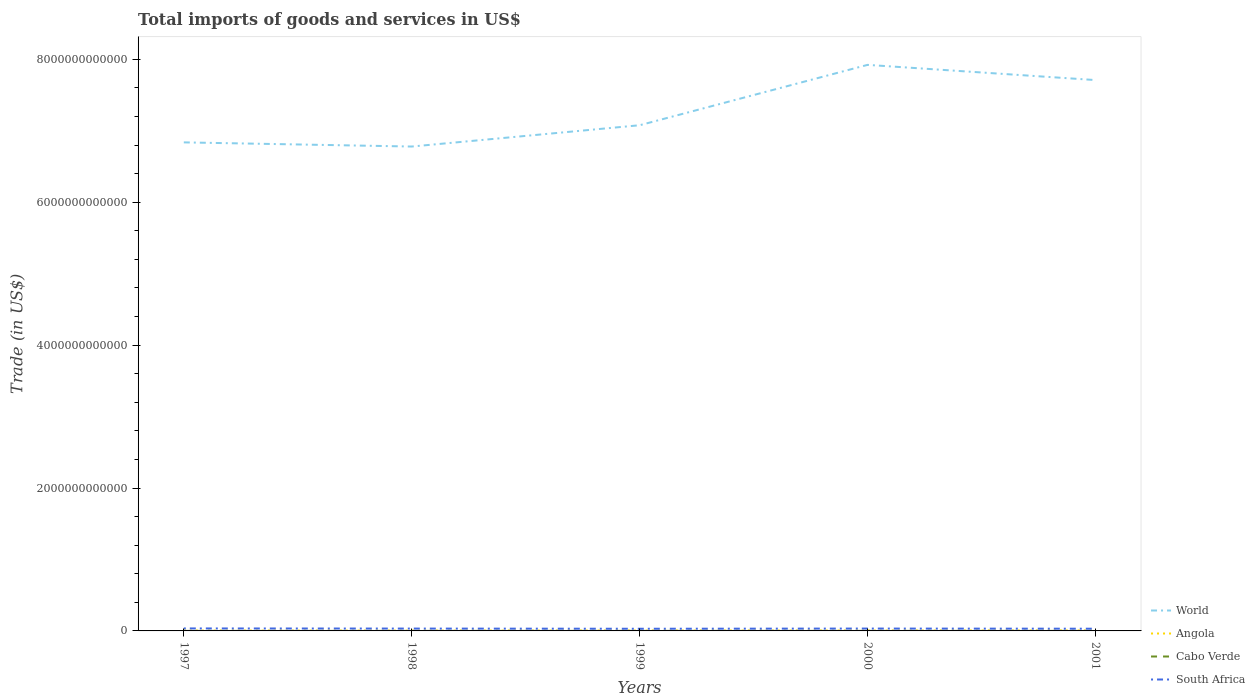How many different coloured lines are there?
Make the answer very short. 4. Across all years, what is the maximum total imports of goods and services in Cabo Verde?
Your response must be concise. 2.87e+08. What is the total total imports of goods and services in Cabo Verde in the graph?
Keep it short and to the point. 4.34e+06. What is the difference between the highest and the second highest total imports of goods and services in Angola?
Keep it short and to the point. 1.98e+09. What is the difference between the highest and the lowest total imports of goods and services in South Africa?
Provide a short and direct response. 3. How many lines are there?
Offer a terse response. 4. What is the difference between two consecutive major ticks on the Y-axis?
Make the answer very short. 2.00e+12. Does the graph contain grids?
Give a very brief answer. No. How are the legend labels stacked?
Keep it short and to the point. Vertical. What is the title of the graph?
Offer a terse response. Total imports of goods and services in US$. Does "Lao PDR" appear as one of the legend labels in the graph?
Your answer should be compact. No. What is the label or title of the X-axis?
Give a very brief answer. Years. What is the label or title of the Y-axis?
Offer a terse response. Trade (in US$). What is the Trade (in US$) in World in 1997?
Ensure brevity in your answer.  6.84e+12. What is the Trade (in US$) of Angola in 1997?
Provide a short and direct response. 5.29e+09. What is the Trade (in US$) in Cabo Verde in 1997?
Offer a very short reply. 2.87e+08. What is the Trade (in US$) of South Africa in 1997?
Provide a succinct answer. 3.49e+1. What is the Trade (in US$) of World in 1998?
Provide a short and direct response. 6.78e+12. What is the Trade (in US$) in Angola in 1998?
Give a very brief answer. 4.71e+09. What is the Trade (in US$) of Cabo Verde in 1998?
Your response must be concise. 3.08e+08. What is the Trade (in US$) in South Africa in 1998?
Give a very brief answer. 3.29e+1. What is the Trade (in US$) of World in 1999?
Make the answer very short. 7.08e+12. What is the Trade (in US$) in Angola in 1999?
Your answer should be very brief. 5.70e+09. What is the Trade (in US$) in Cabo Verde in 1999?
Provide a short and direct response. 3.55e+08. What is the Trade (in US$) of South Africa in 1999?
Your response must be concise. 3.03e+1. What is the Trade (in US$) of World in 2000?
Your response must be concise. 7.92e+12. What is the Trade (in US$) of Angola in 2000?
Your answer should be compact. 5.74e+09. What is the Trade (in US$) of Cabo Verde in 2000?
Ensure brevity in your answer.  3.26e+08. What is the Trade (in US$) of South Africa in 2000?
Provide a short and direct response. 3.31e+1. What is the Trade (in US$) of World in 2001?
Make the answer very short. 7.71e+12. What is the Trade (in US$) in Angola in 2001?
Provide a short and direct response. 6.70e+09. What is the Trade (in US$) of Cabo Verde in 2001?
Your answer should be compact. 3.51e+08. What is the Trade (in US$) in South Africa in 2001?
Your answer should be compact. 3.09e+1. Across all years, what is the maximum Trade (in US$) in World?
Make the answer very short. 7.92e+12. Across all years, what is the maximum Trade (in US$) in Angola?
Provide a short and direct response. 6.70e+09. Across all years, what is the maximum Trade (in US$) of Cabo Verde?
Provide a short and direct response. 3.55e+08. Across all years, what is the maximum Trade (in US$) in South Africa?
Your response must be concise. 3.49e+1. Across all years, what is the minimum Trade (in US$) in World?
Make the answer very short. 6.78e+12. Across all years, what is the minimum Trade (in US$) of Angola?
Provide a short and direct response. 4.71e+09. Across all years, what is the minimum Trade (in US$) of Cabo Verde?
Your response must be concise. 2.87e+08. Across all years, what is the minimum Trade (in US$) of South Africa?
Provide a short and direct response. 3.03e+1. What is the total Trade (in US$) in World in the graph?
Give a very brief answer. 3.63e+13. What is the total Trade (in US$) in Angola in the graph?
Give a very brief answer. 2.81e+1. What is the total Trade (in US$) of Cabo Verde in the graph?
Make the answer very short. 1.63e+09. What is the total Trade (in US$) in South Africa in the graph?
Your response must be concise. 1.62e+11. What is the difference between the Trade (in US$) in World in 1997 and that in 1998?
Your answer should be compact. 5.82e+1. What is the difference between the Trade (in US$) in Angola in 1997 and that in 1998?
Keep it short and to the point. 5.78e+08. What is the difference between the Trade (in US$) in Cabo Verde in 1997 and that in 1998?
Keep it short and to the point. -2.12e+07. What is the difference between the Trade (in US$) in South Africa in 1997 and that in 1998?
Ensure brevity in your answer.  1.96e+09. What is the difference between the Trade (in US$) in World in 1997 and that in 1999?
Your answer should be very brief. -2.40e+11. What is the difference between the Trade (in US$) of Angola in 1997 and that in 1999?
Provide a succinct answer. -4.11e+08. What is the difference between the Trade (in US$) in Cabo Verde in 1997 and that in 1999?
Your answer should be compact. -6.82e+07. What is the difference between the Trade (in US$) of South Africa in 1997 and that in 1999?
Offer a very short reply. 4.59e+09. What is the difference between the Trade (in US$) of World in 1997 and that in 2000?
Your response must be concise. -1.08e+12. What is the difference between the Trade (in US$) in Angola in 1997 and that in 2000?
Your response must be concise. -4.44e+08. What is the difference between the Trade (in US$) in Cabo Verde in 1997 and that in 2000?
Your response must be concise. -3.91e+07. What is the difference between the Trade (in US$) of South Africa in 1997 and that in 2000?
Your answer should be very brief. 1.77e+09. What is the difference between the Trade (in US$) in World in 1997 and that in 2001?
Provide a succinct answer. -8.72e+11. What is the difference between the Trade (in US$) in Angola in 1997 and that in 2001?
Your answer should be compact. -1.41e+09. What is the difference between the Trade (in US$) in Cabo Verde in 1997 and that in 2001?
Give a very brief answer. -6.39e+07. What is the difference between the Trade (in US$) of South Africa in 1997 and that in 2001?
Provide a short and direct response. 3.98e+09. What is the difference between the Trade (in US$) of World in 1998 and that in 1999?
Keep it short and to the point. -2.98e+11. What is the difference between the Trade (in US$) in Angola in 1998 and that in 1999?
Provide a succinct answer. -9.89e+08. What is the difference between the Trade (in US$) of Cabo Verde in 1998 and that in 1999?
Keep it short and to the point. -4.70e+07. What is the difference between the Trade (in US$) in South Africa in 1998 and that in 1999?
Make the answer very short. 2.63e+09. What is the difference between the Trade (in US$) in World in 1998 and that in 2000?
Offer a terse response. -1.14e+12. What is the difference between the Trade (in US$) in Angola in 1998 and that in 2000?
Provide a succinct answer. -1.02e+09. What is the difference between the Trade (in US$) of Cabo Verde in 1998 and that in 2000?
Your answer should be compact. -1.79e+07. What is the difference between the Trade (in US$) in South Africa in 1998 and that in 2000?
Provide a succinct answer. -1.91e+08. What is the difference between the Trade (in US$) in World in 1998 and that in 2001?
Provide a short and direct response. -9.30e+11. What is the difference between the Trade (in US$) in Angola in 1998 and that in 2001?
Make the answer very short. -1.98e+09. What is the difference between the Trade (in US$) of Cabo Verde in 1998 and that in 2001?
Your response must be concise. -4.27e+07. What is the difference between the Trade (in US$) in South Africa in 1998 and that in 2001?
Offer a very short reply. 2.02e+09. What is the difference between the Trade (in US$) in World in 1999 and that in 2000?
Your answer should be very brief. -8.45e+11. What is the difference between the Trade (in US$) in Angola in 1999 and that in 2000?
Provide a short and direct response. -3.23e+07. What is the difference between the Trade (in US$) in Cabo Verde in 1999 and that in 2000?
Provide a succinct answer. 2.91e+07. What is the difference between the Trade (in US$) in South Africa in 1999 and that in 2000?
Provide a short and direct response. -2.82e+09. What is the difference between the Trade (in US$) of World in 1999 and that in 2001?
Offer a terse response. -6.32e+11. What is the difference between the Trade (in US$) in Angola in 1999 and that in 2001?
Give a very brief answer. -9.94e+08. What is the difference between the Trade (in US$) in Cabo Verde in 1999 and that in 2001?
Your answer should be compact. 4.34e+06. What is the difference between the Trade (in US$) in South Africa in 1999 and that in 2001?
Offer a very short reply. -6.11e+08. What is the difference between the Trade (in US$) in World in 2000 and that in 2001?
Give a very brief answer. 2.13e+11. What is the difference between the Trade (in US$) in Angola in 2000 and that in 2001?
Ensure brevity in your answer.  -9.61e+08. What is the difference between the Trade (in US$) in Cabo Verde in 2000 and that in 2001?
Provide a short and direct response. -2.48e+07. What is the difference between the Trade (in US$) in South Africa in 2000 and that in 2001?
Offer a very short reply. 2.21e+09. What is the difference between the Trade (in US$) of World in 1997 and the Trade (in US$) of Angola in 1998?
Your answer should be very brief. 6.83e+12. What is the difference between the Trade (in US$) of World in 1997 and the Trade (in US$) of Cabo Verde in 1998?
Your answer should be very brief. 6.84e+12. What is the difference between the Trade (in US$) of World in 1997 and the Trade (in US$) of South Africa in 1998?
Give a very brief answer. 6.80e+12. What is the difference between the Trade (in US$) in Angola in 1997 and the Trade (in US$) in Cabo Verde in 1998?
Your answer should be compact. 4.98e+09. What is the difference between the Trade (in US$) of Angola in 1997 and the Trade (in US$) of South Africa in 1998?
Offer a very short reply. -2.76e+1. What is the difference between the Trade (in US$) in Cabo Verde in 1997 and the Trade (in US$) in South Africa in 1998?
Ensure brevity in your answer.  -3.26e+1. What is the difference between the Trade (in US$) of World in 1997 and the Trade (in US$) of Angola in 1999?
Your answer should be compact. 6.83e+12. What is the difference between the Trade (in US$) in World in 1997 and the Trade (in US$) in Cabo Verde in 1999?
Make the answer very short. 6.84e+12. What is the difference between the Trade (in US$) of World in 1997 and the Trade (in US$) of South Africa in 1999?
Your answer should be compact. 6.81e+12. What is the difference between the Trade (in US$) in Angola in 1997 and the Trade (in US$) in Cabo Verde in 1999?
Give a very brief answer. 4.94e+09. What is the difference between the Trade (in US$) of Angola in 1997 and the Trade (in US$) of South Africa in 1999?
Offer a very short reply. -2.50e+1. What is the difference between the Trade (in US$) in Cabo Verde in 1997 and the Trade (in US$) in South Africa in 1999?
Your response must be concise. -3.00e+1. What is the difference between the Trade (in US$) in World in 1997 and the Trade (in US$) in Angola in 2000?
Offer a terse response. 6.83e+12. What is the difference between the Trade (in US$) of World in 1997 and the Trade (in US$) of Cabo Verde in 2000?
Offer a terse response. 6.84e+12. What is the difference between the Trade (in US$) in World in 1997 and the Trade (in US$) in South Africa in 2000?
Make the answer very short. 6.80e+12. What is the difference between the Trade (in US$) in Angola in 1997 and the Trade (in US$) in Cabo Verde in 2000?
Keep it short and to the point. 4.97e+09. What is the difference between the Trade (in US$) of Angola in 1997 and the Trade (in US$) of South Africa in 2000?
Your answer should be very brief. -2.78e+1. What is the difference between the Trade (in US$) in Cabo Verde in 1997 and the Trade (in US$) in South Africa in 2000?
Offer a very short reply. -3.28e+1. What is the difference between the Trade (in US$) of World in 1997 and the Trade (in US$) of Angola in 2001?
Give a very brief answer. 6.83e+12. What is the difference between the Trade (in US$) in World in 1997 and the Trade (in US$) in Cabo Verde in 2001?
Your response must be concise. 6.84e+12. What is the difference between the Trade (in US$) of World in 1997 and the Trade (in US$) of South Africa in 2001?
Your answer should be compact. 6.81e+12. What is the difference between the Trade (in US$) in Angola in 1997 and the Trade (in US$) in Cabo Verde in 2001?
Offer a very short reply. 4.94e+09. What is the difference between the Trade (in US$) of Angola in 1997 and the Trade (in US$) of South Africa in 2001?
Keep it short and to the point. -2.56e+1. What is the difference between the Trade (in US$) of Cabo Verde in 1997 and the Trade (in US$) of South Africa in 2001?
Your answer should be compact. -3.06e+1. What is the difference between the Trade (in US$) of World in 1998 and the Trade (in US$) of Angola in 1999?
Give a very brief answer. 6.77e+12. What is the difference between the Trade (in US$) in World in 1998 and the Trade (in US$) in Cabo Verde in 1999?
Your answer should be compact. 6.78e+12. What is the difference between the Trade (in US$) in World in 1998 and the Trade (in US$) in South Africa in 1999?
Offer a terse response. 6.75e+12. What is the difference between the Trade (in US$) of Angola in 1998 and the Trade (in US$) of Cabo Verde in 1999?
Offer a very short reply. 4.36e+09. What is the difference between the Trade (in US$) of Angola in 1998 and the Trade (in US$) of South Africa in 1999?
Provide a short and direct response. -2.56e+1. What is the difference between the Trade (in US$) of Cabo Verde in 1998 and the Trade (in US$) of South Africa in 1999?
Give a very brief answer. -3.00e+1. What is the difference between the Trade (in US$) of World in 1998 and the Trade (in US$) of Angola in 2000?
Make the answer very short. 6.77e+12. What is the difference between the Trade (in US$) in World in 1998 and the Trade (in US$) in Cabo Verde in 2000?
Keep it short and to the point. 6.78e+12. What is the difference between the Trade (in US$) of World in 1998 and the Trade (in US$) of South Africa in 2000?
Keep it short and to the point. 6.75e+12. What is the difference between the Trade (in US$) in Angola in 1998 and the Trade (in US$) in Cabo Verde in 2000?
Keep it short and to the point. 4.39e+09. What is the difference between the Trade (in US$) of Angola in 1998 and the Trade (in US$) of South Africa in 2000?
Provide a short and direct response. -2.84e+1. What is the difference between the Trade (in US$) of Cabo Verde in 1998 and the Trade (in US$) of South Africa in 2000?
Provide a short and direct response. -3.28e+1. What is the difference between the Trade (in US$) of World in 1998 and the Trade (in US$) of Angola in 2001?
Offer a very short reply. 6.77e+12. What is the difference between the Trade (in US$) in World in 1998 and the Trade (in US$) in Cabo Verde in 2001?
Provide a short and direct response. 6.78e+12. What is the difference between the Trade (in US$) of World in 1998 and the Trade (in US$) of South Africa in 2001?
Offer a terse response. 6.75e+12. What is the difference between the Trade (in US$) of Angola in 1998 and the Trade (in US$) of Cabo Verde in 2001?
Provide a succinct answer. 4.36e+09. What is the difference between the Trade (in US$) in Angola in 1998 and the Trade (in US$) in South Africa in 2001?
Your response must be concise. -2.62e+1. What is the difference between the Trade (in US$) of Cabo Verde in 1998 and the Trade (in US$) of South Africa in 2001?
Your answer should be compact. -3.06e+1. What is the difference between the Trade (in US$) of World in 1999 and the Trade (in US$) of Angola in 2000?
Your answer should be very brief. 7.07e+12. What is the difference between the Trade (in US$) in World in 1999 and the Trade (in US$) in Cabo Verde in 2000?
Your answer should be very brief. 7.08e+12. What is the difference between the Trade (in US$) of World in 1999 and the Trade (in US$) of South Africa in 2000?
Provide a succinct answer. 7.04e+12. What is the difference between the Trade (in US$) in Angola in 1999 and the Trade (in US$) in Cabo Verde in 2000?
Offer a very short reply. 5.38e+09. What is the difference between the Trade (in US$) in Angola in 1999 and the Trade (in US$) in South Africa in 2000?
Offer a very short reply. -2.74e+1. What is the difference between the Trade (in US$) in Cabo Verde in 1999 and the Trade (in US$) in South Africa in 2000?
Give a very brief answer. -3.28e+1. What is the difference between the Trade (in US$) of World in 1999 and the Trade (in US$) of Angola in 2001?
Your answer should be very brief. 7.07e+12. What is the difference between the Trade (in US$) of World in 1999 and the Trade (in US$) of Cabo Verde in 2001?
Offer a very short reply. 7.08e+12. What is the difference between the Trade (in US$) in World in 1999 and the Trade (in US$) in South Africa in 2001?
Keep it short and to the point. 7.05e+12. What is the difference between the Trade (in US$) in Angola in 1999 and the Trade (in US$) in Cabo Verde in 2001?
Offer a very short reply. 5.35e+09. What is the difference between the Trade (in US$) in Angola in 1999 and the Trade (in US$) in South Africa in 2001?
Your answer should be compact. -2.52e+1. What is the difference between the Trade (in US$) in Cabo Verde in 1999 and the Trade (in US$) in South Africa in 2001?
Provide a short and direct response. -3.05e+1. What is the difference between the Trade (in US$) of World in 2000 and the Trade (in US$) of Angola in 2001?
Keep it short and to the point. 7.92e+12. What is the difference between the Trade (in US$) in World in 2000 and the Trade (in US$) in Cabo Verde in 2001?
Offer a very short reply. 7.92e+12. What is the difference between the Trade (in US$) in World in 2000 and the Trade (in US$) in South Africa in 2001?
Your response must be concise. 7.89e+12. What is the difference between the Trade (in US$) of Angola in 2000 and the Trade (in US$) of Cabo Verde in 2001?
Give a very brief answer. 5.38e+09. What is the difference between the Trade (in US$) of Angola in 2000 and the Trade (in US$) of South Africa in 2001?
Ensure brevity in your answer.  -2.52e+1. What is the difference between the Trade (in US$) in Cabo Verde in 2000 and the Trade (in US$) in South Africa in 2001?
Your answer should be very brief. -3.06e+1. What is the average Trade (in US$) of World per year?
Your answer should be very brief. 7.27e+12. What is the average Trade (in US$) in Angola per year?
Make the answer very short. 5.63e+09. What is the average Trade (in US$) in Cabo Verde per year?
Provide a succinct answer. 3.26e+08. What is the average Trade (in US$) of South Africa per year?
Make the answer very short. 3.24e+1. In the year 1997, what is the difference between the Trade (in US$) of World and Trade (in US$) of Angola?
Offer a very short reply. 6.83e+12. In the year 1997, what is the difference between the Trade (in US$) of World and Trade (in US$) of Cabo Verde?
Provide a succinct answer. 6.84e+12. In the year 1997, what is the difference between the Trade (in US$) of World and Trade (in US$) of South Africa?
Offer a terse response. 6.80e+12. In the year 1997, what is the difference between the Trade (in US$) of Angola and Trade (in US$) of Cabo Verde?
Keep it short and to the point. 5.01e+09. In the year 1997, what is the difference between the Trade (in US$) of Angola and Trade (in US$) of South Africa?
Your response must be concise. -2.96e+1. In the year 1997, what is the difference between the Trade (in US$) of Cabo Verde and Trade (in US$) of South Africa?
Keep it short and to the point. -3.46e+1. In the year 1998, what is the difference between the Trade (in US$) of World and Trade (in US$) of Angola?
Give a very brief answer. 6.77e+12. In the year 1998, what is the difference between the Trade (in US$) in World and Trade (in US$) in Cabo Verde?
Your answer should be very brief. 6.78e+12. In the year 1998, what is the difference between the Trade (in US$) of World and Trade (in US$) of South Africa?
Make the answer very short. 6.75e+12. In the year 1998, what is the difference between the Trade (in US$) of Angola and Trade (in US$) of Cabo Verde?
Your answer should be very brief. 4.41e+09. In the year 1998, what is the difference between the Trade (in US$) of Angola and Trade (in US$) of South Africa?
Ensure brevity in your answer.  -2.82e+1. In the year 1998, what is the difference between the Trade (in US$) in Cabo Verde and Trade (in US$) in South Africa?
Make the answer very short. -3.26e+1. In the year 1999, what is the difference between the Trade (in US$) of World and Trade (in US$) of Angola?
Offer a very short reply. 7.07e+12. In the year 1999, what is the difference between the Trade (in US$) in World and Trade (in US$) in Cabo Verde?
Ensure brevity in your answer.  7.08e+12. In the year 1999, what is the difference between the Trade (in US$) in World and Trade (in US$) in South Africa?
Provide a succinct answer. 7.05e+12. In the year 1999, what is the difference between the Trade (in US$) in Angola and Trade (in US$) in Cabo Verde?
Provide a succinct answer. 5.35e+09. In the year 1999, what is the difference between the Trade (in US$) in Angola and Trade (in US$) in South Africa?
Provide a succinct answer. -2.46e+1. In the year 1999, what is the difference between the Trade (in US$) of Cabo Verde and Trade (in US$) of South Africa?
Provide a short and direct response. -2.99e+1. In the year 2000, what is the difference between the Trade (in US$) of World and Trade (in US$) of Angola?
Offer a terse response. 7.92e+12. In the year 2000, what is the difference between the Trade (in US$) of World and Trade (in US$) of Cabo Verde?
Make the answer very short. 7.92e+12. In the year 2000, what is the difference between the Trade (in US$) of World and Trade (in US$) of South Africa?
Offer a very short reply. 7.89e+12. In the year 2000, what is the difference between the Trade (in US$) of Angola and Trade (in US$) of Cabo Verde?
Your answer should be compact. 5.41e+09. In the year 2000, what is the difference between the Trade (in US$) of Angola and Trade (in US$) of South Africa?
Keep it short and to the point. -2.74e+1. In the year 2000, what is the difference between the Trade (in US$) in Cabo Verde and Trade (in US$) in South Africa?
Offer a very short reply. -3.28e+1. In the year 2001, what is the difference between the Trade (in US$) of World and Trade (in US$) of Angola?
Offer a very short reply. 7.70e+12. In the year 2001, what is the difference between the Trade (in US$) in World and Trade (in US$) in Cabo Verde?
Give a very brief answer. 7.71e+12. In the year 2001, what is the difference between the Trade (in US$) in World and Trade (in US$) in South Africa?
Keep it short and to the point. 7.68e+12. In the year 2001, what is the difference between the Trade (in US$) in Angola and Trade (in US$) in Cabo Verde?
Provide a short and direct response. 6.35e+09. In the year 2001, what is the difference between the Trade (in US$) in Angola and Trade (in US$) in South Africa?
Provide a succinct answer. -2.42e+1. In the year 2001, what is the difference between the Trade (in US$) in Cabo Verde and Trade (in US$) in South Africa?
Keep it short and to the point. -3.05e+1. What is the ratio of the Trade (in US$) in World in 1997 to that in 1998?
Your response must be concise. 1.01. What is the ratio of the Trade (in US$) of Angola in 1997 to that in 1998?
Provide a succinct answer. 1.12. What is the ratio of the Trade (in US$) of Cabo Verde in 1997 to that in 1998?
Provide a short and direct response. 0.93. What is the ratio of the Trade (in US$) of South Africa in 1997 to that in 1998?
Make the answer very short. 1.06. What is the ratio of the Trade (in US$) in World in 1997 to that in 1999?
Provide a short and direct response. 0.97. What is the ratio of the Trade (in US$) of Angola in 1997 to that in 1999?
Offer a terse response. 0.93. What is the ratio of the Trade (in US$) in Cabo Verde in 1997 to that in 1999?
Your answer should be compact. 0.81. What is the ratio of the Trade (in US$) in South Africa in 1997 to that in 1999?
Provide a succinct answer. 1.15. What is the ratio of the Trade (in US$) in World in 1997 to that in 2000?
Your response must be concise. 0.86. What is the ratio of the Trade (in US$) in Angola in 1997 to that in 2000?
Provide a succinct answer. 0.92. What is the ratio of the Trade (in US$) in Cabo Verde in 1997 to that in 2000?
Keep it short and to the point. 0.88. What is the ratio of the Trade (in US$) in South Africa in 1997 to that in 2000?
Make the answer very short. 1.05. What is the ratio of the Trade (in US$) of World in 1997 to that in 2001?
Offer a very short reply. 0.89. What is the ratio of the Trade (in US$) in Angola in 1997 to that in 2001?
Your answer should be very brief. 0.79. What is the ratio of the Trade (in US$) in Cabo Verde in 1997 to that in 2001?
Keep it short and to the point. 0.82. What is the ratio of the Trade (in US$) of South Africa in 1997 to that in 2001?
Offer a very short reply. 1.13. What is the ratio of the Trade (in US$) of World in 1998 to that in 1999?
Provide a short and direct response. 0.96. What is the ratio of the Trade (in US$) of Angola in 1998 to that in 1999?
Give a very brief answer. 0.83. What is the ratio of the Trade (in US$) in Cabo Verde in 1998 to that in 1999?
Your response must be concise. 0.87. What is the ratio of the Trade (in US$) in South Africa in 1998 to that in 1999?
Keep it short and to the point. 1.09. What is the ratio of the Trade (in US$) in World in 1998 to that in 2000?
Keep it short and to the point. 0.86. What is the ratio of the Trade (in US$) of Angola in 1998 to that in 2000?
Give a very brief answer. 0.82. What is the ratio of the Trade (in US$) in Cabo Verde in 1998 to that in 2000?
Offer a terse response. 0.94. What is the ratio of the Trade (in US$) of South Africa in 1998 to that in 2000?
Provide a short and direct response. 0.99. What is the ratio of the Trade (in US$) in World in 1998 to that in 2001?
Offer a terse response. 0.88. What is the ratio of the Trade (in US$) in Angola in 1998 to that in 2001?
Your answer should be very brief. 0.7. What is the ratio of the Trade (in US$) of Cabo Verde in 1998 to that in 2001?
Your response must be concise. 0.88. What is the ratio of the Trade (in US$) of South Africa in 1998 to that in 2001?
Your response must be concise. 1.07. What is the ratio of the Trade (in US$) in World in 1999 to that in 2000?
Your answer should be compact. 0.89. What is the ratio of the Trade (in US$) of Angola in 1999 to that in 2000?
Offer a terse response. 0.99. What is the ratio of the Trade (in US$) of Cabo Verde in 1999 to that in 2000?
Your response must be concise. 1.09. What is the ratio of the Trade (in US$) in South Africa in 1999 to that in 2000?
Your answer should be very brief. 0.91. What is the ratio of the Trade (in US$) in World in 1999 to that in 2001?
Offer a terse response. 0.92. What is the ratio of the Trade (in US$) of Angola in 1999 to that in 2001?
Your answer should be compact. 0.85. What is the ratio of the Trade (in US$) in Cabo Verde in 1999 to that in 2001?
Offer a very short reply. 1.01. What is the ratio of the Trade (in US$) of South Africa in 1999 to that in 2001?
Your answer should be compact. 0.98. What is the ratio of the Trade (in US$) of World in 2000 to that in 2001?
Give a very brief answer. 1.03. What is the ratio of the Trade (in US$) of Angola in 2000 to that in 2001?
Provide a succinct answer. 0.86. What is the ratio of the Trade (in US$) in Cabo Verde in 2000 to that in 2001?
Your answer should be very brief. 0.93. What is the ratio of the Trade (in US$) in South Africa in 2000 to that in 2001?
Keep it short and to the point. 1.07. What is the difference between the highest and the second highest Trade (in US$) of World?
Your response must be concise. 2.13e+11. What is the difference between the highest and the second highest Trade (in US$) in Angola?
Provide a short and direct response. 9.61e+08. What is the difference between the highest and the second highest Trade (in US$) in Cabo Verde?
Give a very brief answer. 4.34e+06. What is the difference between the highest and the second highest Trade (in US$) of South Africa?
Your answer should be compact. 1.77e+09. What is the difference between the highest and the lowest Trade (in US$) in World?
Ensure brevity in your answer.  1.14e+12. What is the difference between the highest and the lowest Trade (in US$) in Angola?
Ensure brevity in your answer.  1.98e+09. What is the difference between the highest and the lowest Trade (in US$) of Cabo Verde?
Your answer should be compact. 6.82e+07. What is the difference between the highest and the lowest Trade (in US$) in South Africa?
Provide a succinct answer. 4.59e+09. 